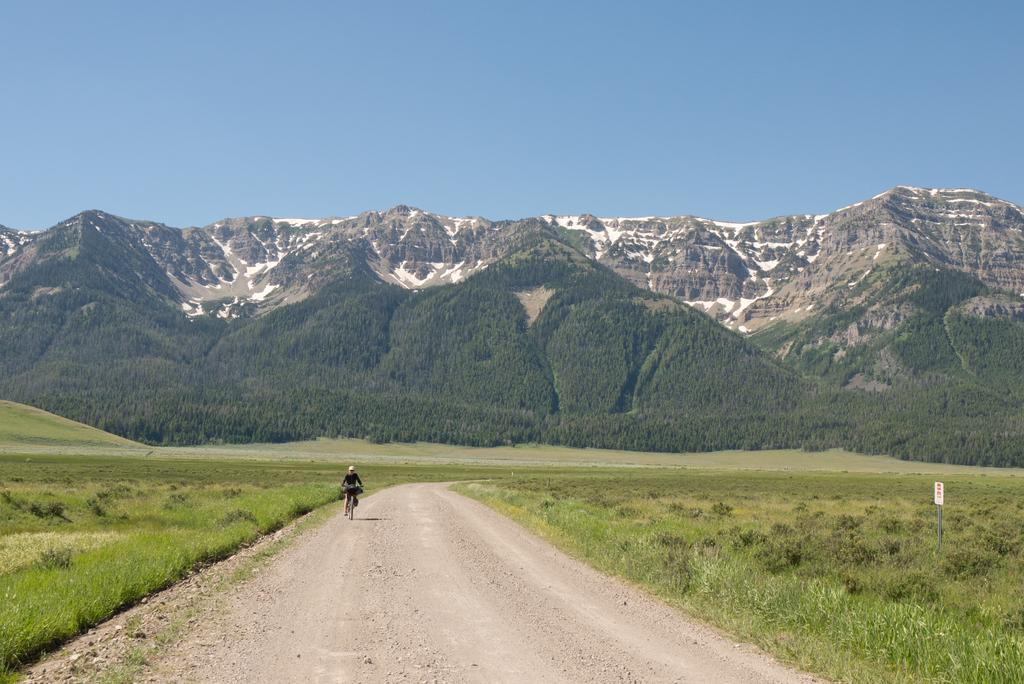What is the main subject of the image? There is a person riding a bicycle in the image. Where is the person riding the bicycle? The person is on the road. What can be seen in the background of the image? There are hills in the background of the image. What is visible at the top of the image? The sky is visible at the top of the image. What is visible at the bottom of the image? The ground is visible at the bottom of the image. Where is the nearest library to the person riding the bicycle in the image? There is no information about a library in the image, so it cannot be determined. 